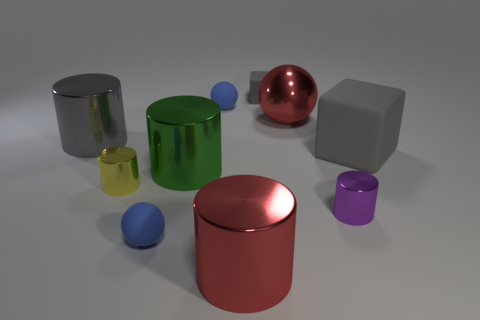What number of things are either purple metal objects right of the red ball or tiny balls?
Offer a terse response. 3. Is the large block that is right of the big red shiny ball made of the same material as the gray cylinder?
Give a very brief answer. No. Is the tiny gray object the same shape as the large matte thing?
Provide a short and direct response. Yes. There is a gray shiny object that is behind the big block; what number of large balls are behind it?
Provide a succinct answer. 1. There is a large gray thing that is the same shape as the tiny gray thing; what is it made of?
Offer a terse response. Rubber. There is a shiny object left of the small yellow cylinder; does it have the same color as the big matte block?
Make the answer very short. Yes. Do the purple cylinder and the small blue thing behind the yellow object have the same material?
Give a very brief answer. No. The blue thing right of the large green thing has what shape?
Ensure brevity in your answer.  Sphere. What number of other objects are the same material as the small purple object?
Provide a short and direct response. 5. The shiny ball is what size?
Keep it short and to the point. Large. 